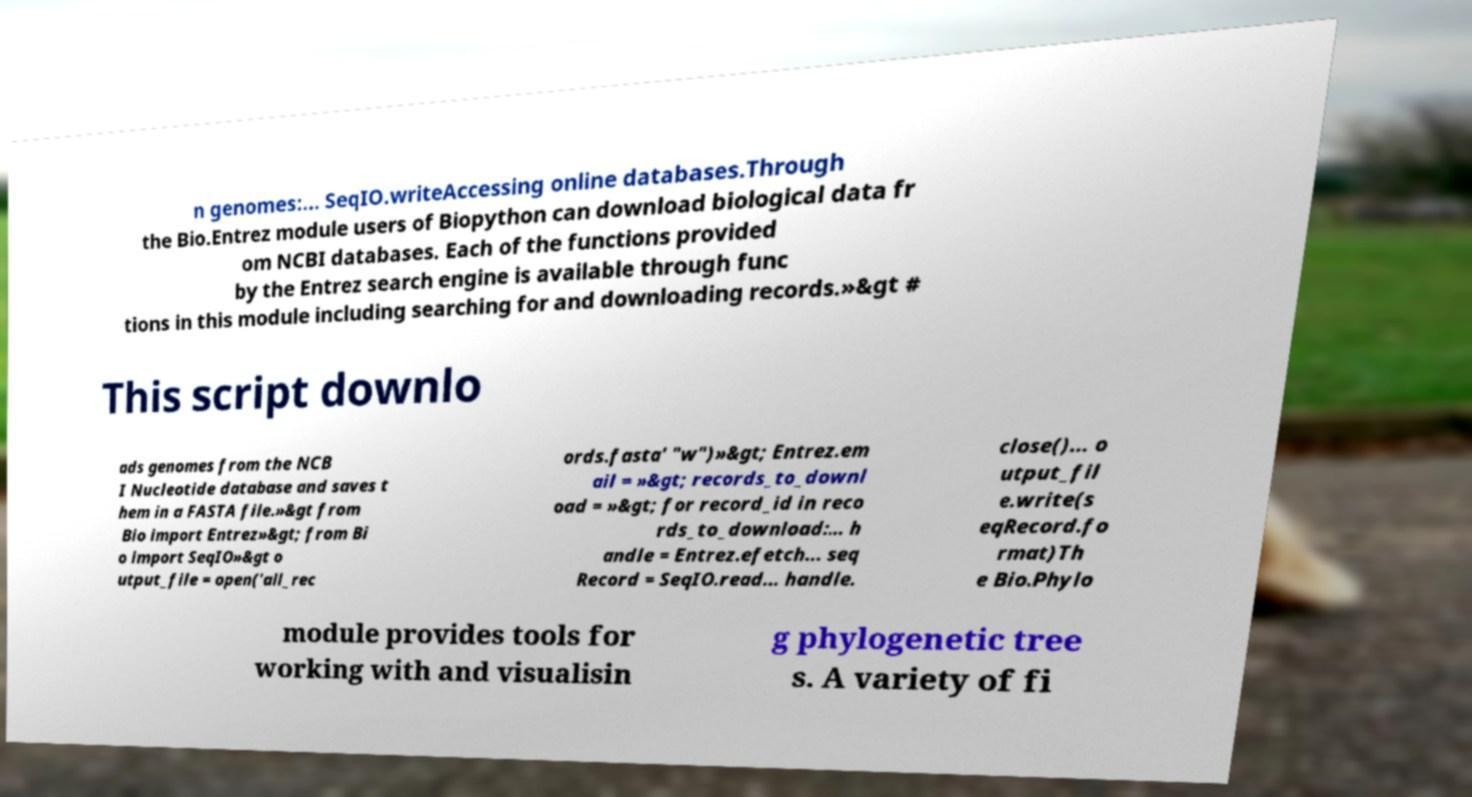Can you accurately transcribe the text from the provided image for me? n genomes:... SeqIO.writeAccessing online databases.Through the Bio.Entrez module users of Biopython can download biological data fr om NCBI databases. Each of the functions provided by the Entrez search engine is available through func tions in this module including searching for and downloading records.»&gt # This script downlo ads genomes from the NCB I Nucleotide database and saves t hem in a FASTA file.»&gt from Bio import Entrez»&gt; from Bi o import SeqIO»&gt o utput_file = open('all_rec ords.fasta' "w")»&gt; Entrez.em ail = »&gt; records_to_downl oad = »&gt; for record_id in reco rds_to_download:... h andle = Entrez.efetch... seq Record = SeqIO.read... handle. close()... o utput_fil e.write(s eqRecord.fo rmat)Th e Bio.Phylo module provides tools for working with and visualisin g phylogenetic tree s. A variety of fi 